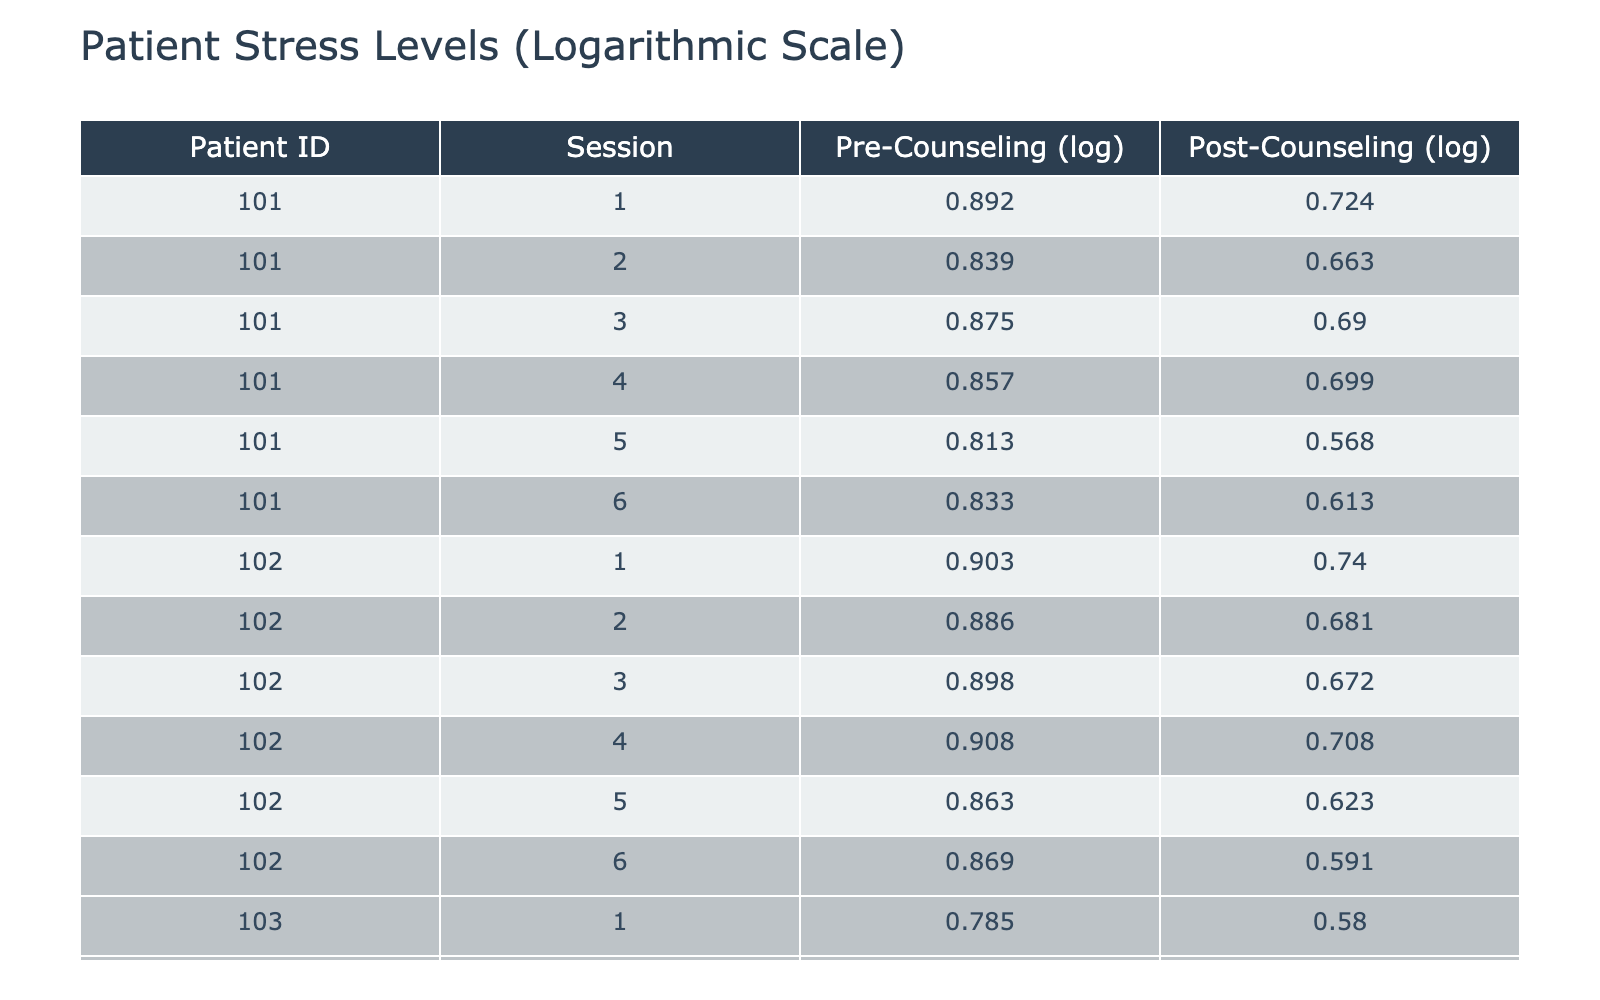What is the logarithmic Pre-Counseling stress level for Patient ID 102 during Session 3? From the table, we locate Patient ID 102 and find Session 3. The Pre-Counseling stress level for this session is listed as 7.9. Taking the logarithm (base 10), the value is approximately 0.897.
Answer: 0.897 What is the logarithmic Post-Counseling stress level for Patient ID 104 during Session 5? Patient ID 104's Session 5 shows a Post-Counseling stress level of 5.1. The logarithmic value calculated for this is approximately 0.707.
Answer: 0.707 Which patient had the highest Pre-Counseling stress level across all sessions? By reviewing the Pre-Counseling stress levels, we find that Patient ID 104 had the highest value of 9.2 in Session 1.
Answer: Patient ID 104 Is the Post-Counseling stress level lower for at least one session compared to its Pre-Counseling level for Patient ID 101? Checking the data for Patient ID 101, in Session 5, the Pre-Counseling stress level is 6.5, and the Post-Counseling level is 3.7, which confirms the Post level is lower.
Answer: Yes What is the average logarithmic change in stress level (Post-Counseling minus Pre-Counseling) for Patient ID 103? For Patient ID 103, we will calculate the difference for each session and find the average. The differences are: (3.8 - 6.1), (3.5 - 6.0), (3.4 - 6.4), (3.6 - 6.5), (3.3 - 6.2), (3.1 - 6.3), resulting in the differences of -2.3, -2.5, -3.0, -2.9, -2.9, -3.2. The average is (-2.3 - 2.5 - 3.0 - 2.9 - 2.9 - 3.2)/6 = -2.67.
Answer: -2.67 Did Patient ID 102 show an improvement in stress levels from Pre-Counseling to Post-Counseling across all sessions? Evaluating Patient ID 102, we see that all Post-Counseling stress levels are lower than their corresponding Pre-Counseling levels for all sessions, indicating improvement across the board.
Answer: Yes What is the median logarithmic Pre-Counseling stress level for all patients? The Pre-Counseling logarithmic values calculated are 0.892, 0.886, 0.806, 0.964, 0.923, and 0.845. The median is the average of the 3rd and 4th values when ordered, which equals (0.892 + 0.886)/2 = 0.889.
Answer: 0.889 